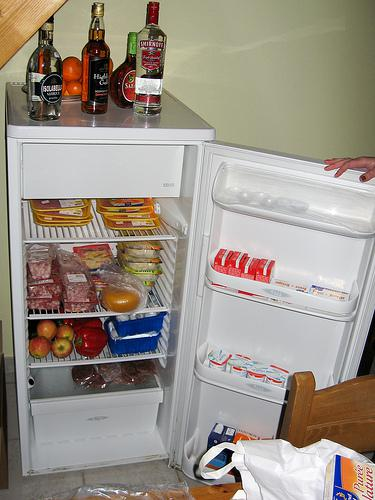Question: what is in the fridge?
Choices:
A. Water.
B. Food.
C. Cola.
D. Dishes.
Answer with the letter. Answer: B Question: where is this picture taken?
Choices:
A. Bathroom.
B. Closet.
C. Dining room.
D. Kitchen.
Answer with the letter. Answer: D Question: what does this picture show?
Choices:
A. Food.
B. Drinks.
C. Plants.
D. Animals.
Answer with the letter. Answer: A Question: who took this picture?
Choices:
A. A dog.
B. A person.
C. An alien.
D. A cat.
Answer with the letter. Answer: B Question: how many bottles are there?
Choices:
A. Three.
B. Two.
C. None.
D. Four.
Answer with the letter. Answer: D Question: what is on the top shelf?
Choices:
A. Milk.
B. Cheese.
C. Meat.
D. Vegetables.
Answer with the letter. Answer: C Question: what is in the bottles?
Choices:
A. Alcohol.
B. Water.
C. Cola.
D. Milk.
Answer with the letter. Answer: A 